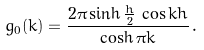Convert formula to latex. <formula><loc_0><loc_0><loc_500><loc_500>g _ { 0 } ( k ) = \frac { 2 \pi \sinh \frac { h } { 2 } \, \cos k h } { \cosh \pi k } \, .</formula> 